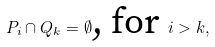Convert formula to latex. <formula><loc_0><loc_0><loc_500><loc_500>P _ { i } \cap Q _ { k } = \emptyset \text {, for } i > k ,</formula> 